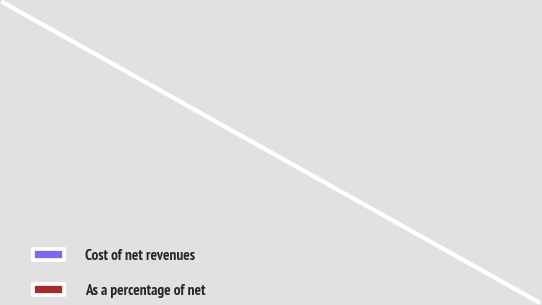Convert chart to OTSL. <chart><loc_0><loc_0><loc_500><loc_500><pie_chart><fcel>Cost of net revenues<fcel>As a percentage of net<nl><fcel>100.0%<fcel>0.0%<nl></chart> 